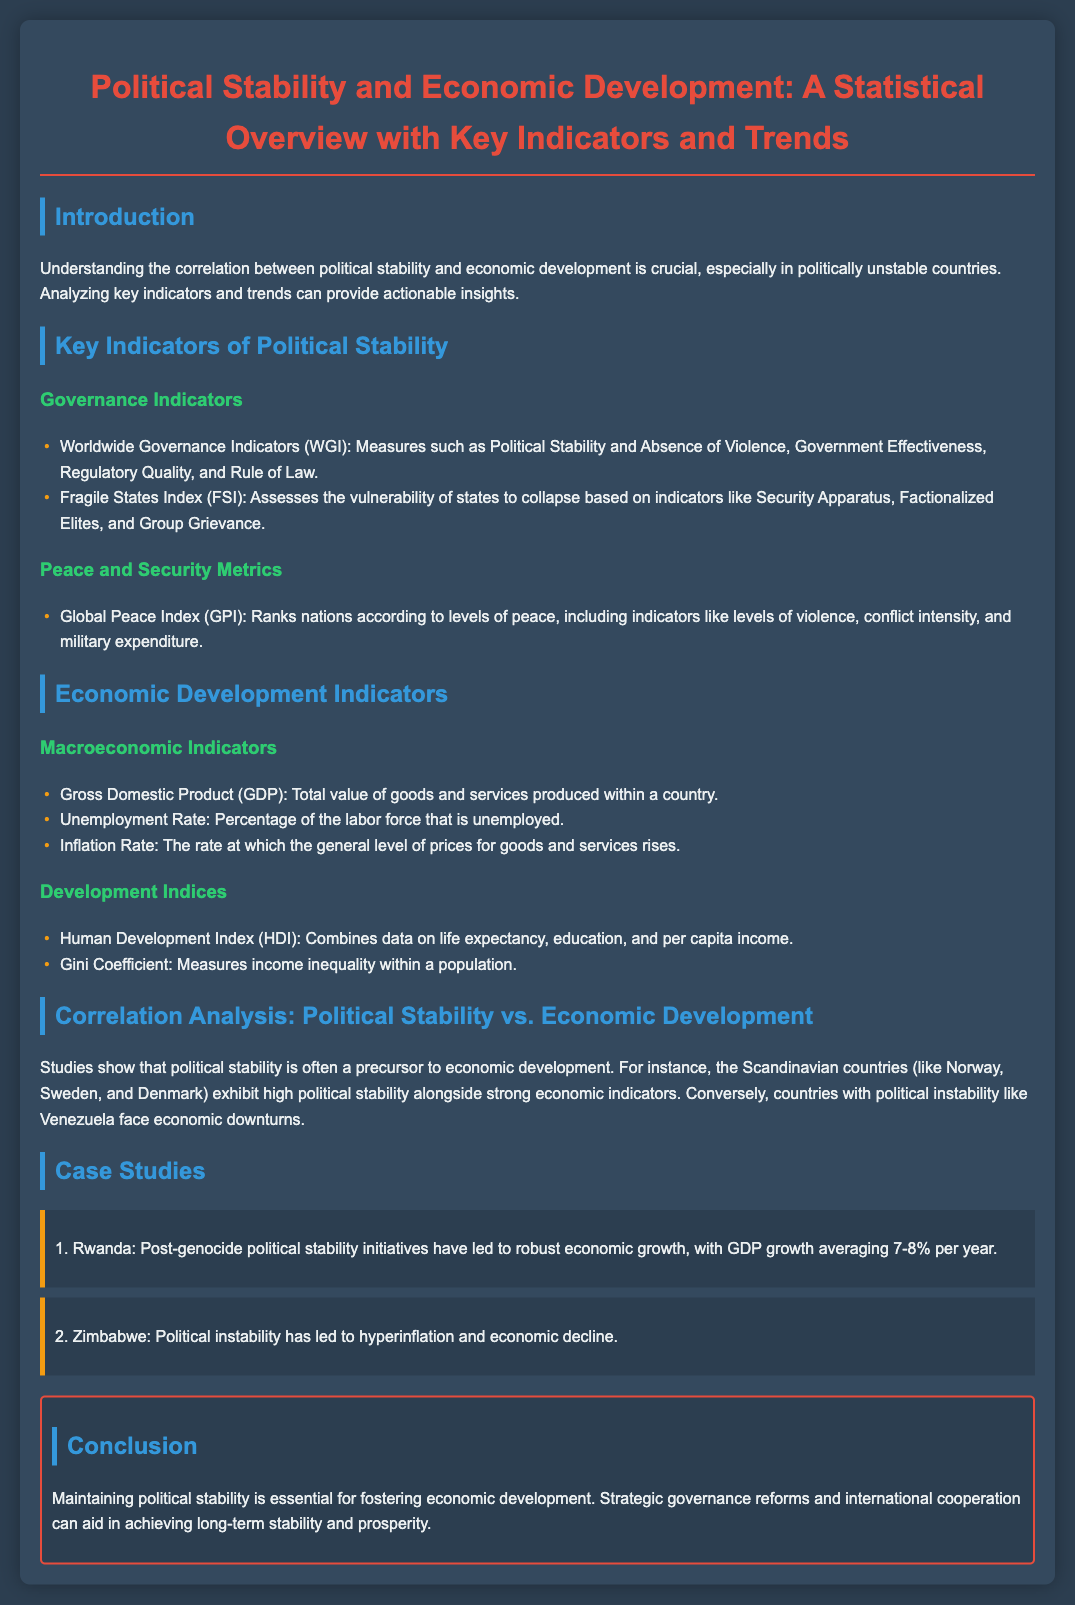what are the Worldwide Governance Indicators? The document lists the Worldwide Governance Indicators as measures including Political Stability and Absence of Violence, Government Effectiveness, Regulatory Quality, and Rule of Law.
Answer: Worldwide Governance Indicators: Political Stability and Absence of Violence, Government Effectiveness, Regulatory Quality, and Rule of Law what is the GDP defined as? The document defines GDP as the total value of goods and services produced within a country.
Answer: Total value of goods and services produced within a country what country is mentioned as experiencing hyperinflation? The document states Zimbabwe as the country that has faced hyperinflation and economic decline due to political instability.
Answer: Zimbabwe what is the average GDP growth rate of Rwanda? According to the document, Rwanda's GDP growth averages 7-8% per year.
Answer: 7-8% what does the Global Peace Index rank countries by? The document explains that the Global Peace Index ranks nations according to levels of peace, including various indicators like levels of violence and conflict intensity.
Answer: Levels of peace how are political stability and economic development correlated according to the document? The document states that studies show political stability is often a precursor to economic development, providing examples of countries with strong indicators next to high political stability.
Answer: Precursor to economic development what is the main conclusion of the presentation? The final section of the document concludes that maintaining political stability is essential for fostering economic development.
Answer: Essential for fostering economic development what does the Gini Coefficient measure? The document describes the Gini Coefficient as a measure of income inequality within a population.
Answer: Income inequality within a population 